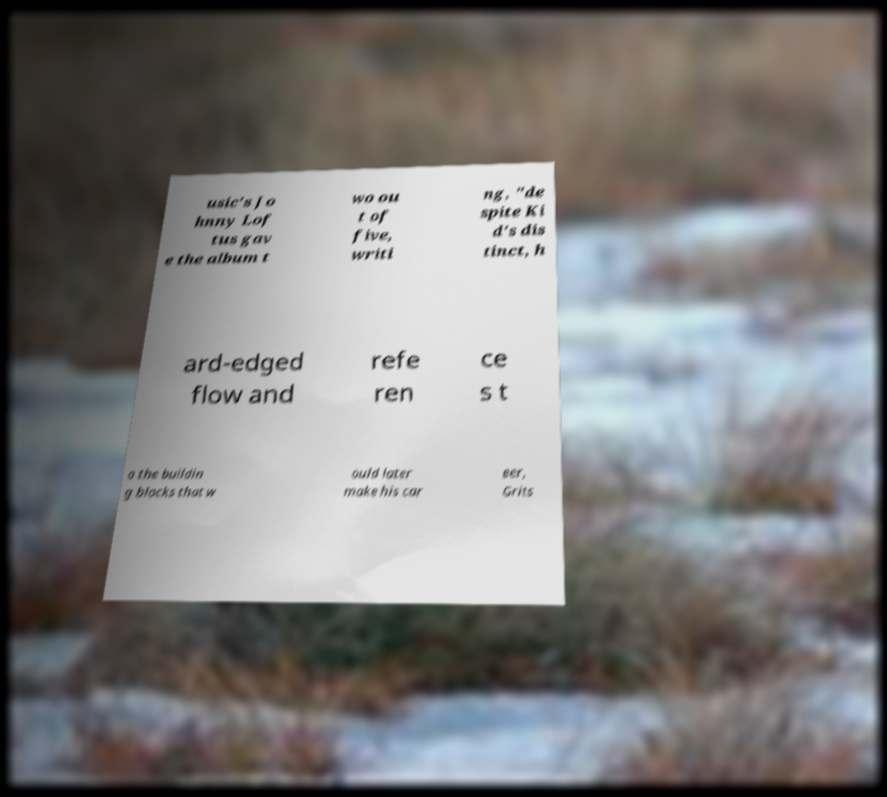Could you extract and type out the text from this image? usic's Jo hnny Lof tus gav e the album t wo ou t of five, writi ng, "de spite Ki d's dis tinct, h ard-edged flow and refe ren ce s t o the buildin g blocks that w ould later make his car eer, Grits 